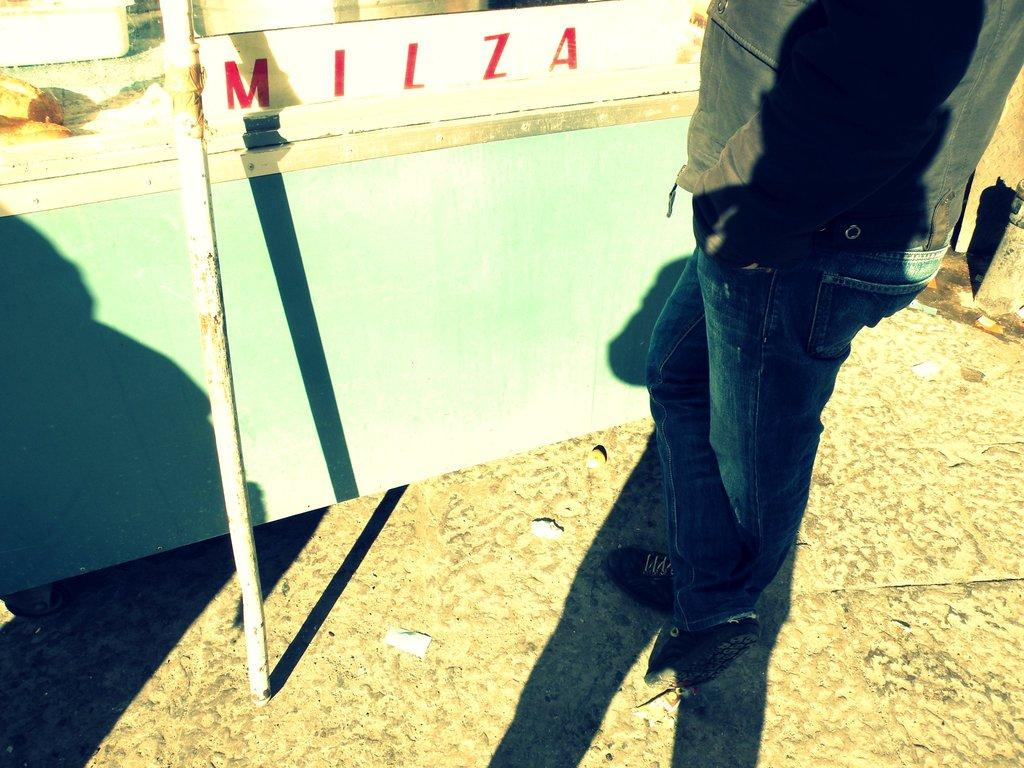What is the person in the image doing? The person is standing on the ground in the image. What can be seen in the image besides the person? There is a shadow and a pole in the image. What type of steel is the worm made of in the image? There is no worm present in the image, and therefore no such material can be identified. 